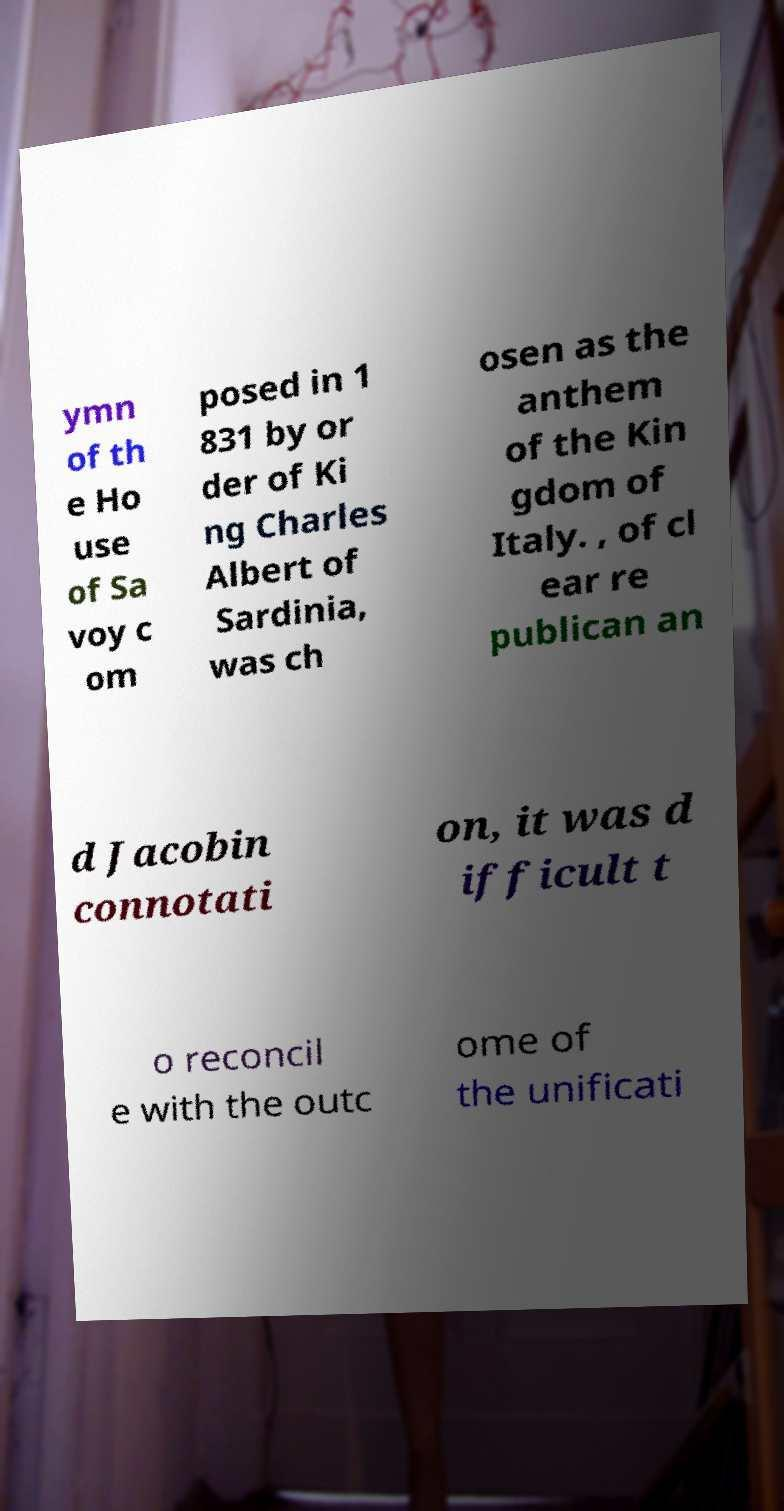Could you extract and type out the text from this image? ymn of th e Ho use of Sa voy c om posed in 1 831 by or der of Ki ng Charles Albert of Sardinia, was ch osen as the anthem of the Kin gdom of Italy. , of cl ear re publican an d Jacobin connotati on, it was d ifficult t o reconcil e with the outc ome of the unificati 